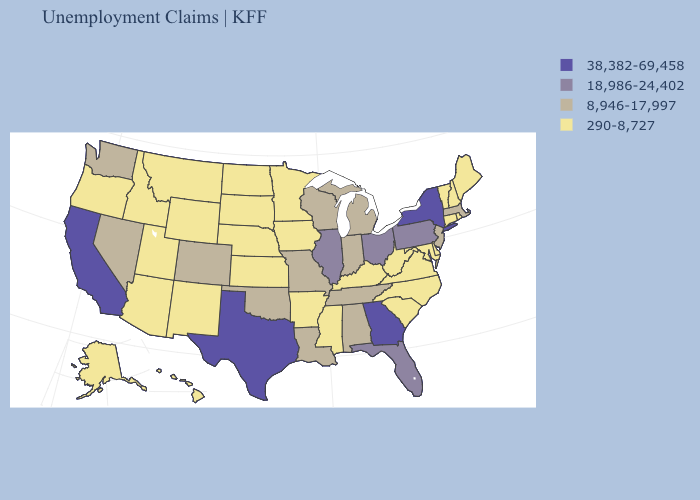Name the states that have a value in the range 290-8,727?
Answer briefly. Alaska, Arizona, Arkansas, Connecticut, Delaware, Hawaii, Idaho, Iowa, Kansas, Kentucky, Maine, Maryland, Minnesota, Mississippi, Montana, Nebraska, New Hampshire, New Mexico, North Carolina, North Dakota, Oregon, Rhode Island, South Carolina, South Dakota, Utah, Vermont, Virginia, West Virginia, Wyoming. Does Virginia have the highest value in the USA?
Quick response, please. No. Name the states that have a value in the range 8,946-17,997?
Answer briefly. Alabama, Colorado, Indiana, Louisiana, Massachusetts, Michigan, Missouri, Nevada, New Jersey, Oklahoma, Tennessee, Washington, Wisconsin. What is the value of South Carolina?
Short answer required. 290-8,727. What is the value of Connecticut?
Write a very short answer. 290-8,727. Among the states that border Minnesota , does Wisconsin have the highest value?
Quick response, please. Yes. Which states have the lowest value in the USA?
Concise answer only. Alaska, Arizona, Arkansas, Connecticut, Delaware, Hawaii, Idaho, Iowa, Kansas, Kentucky, Maine, Maryland, Minnesota, Mississippi, Montana, Nebraska, New Hampshire, New Mexico, North Carolina, North Dakota, Oregon, Rhode Island, South Carolina, South Dakota, Utah, Vermont, Virginia, West Virginia, Wyoming. What is the highest value in states that border Delaware?
Answer briefly. 18,986-24,402. Is the legend a continuous bar?
Keep it brief. No. Name the states that have a value in the range 38,382-69,458?
Keep it brief. California, Georgia, New York, Texas. Name the states that have a value in the range 38,382-69,458?
Write a very short answer. California, Georgia, New York, Texas. What is the lowest value in the West?
Keep it brief. 290-8,727. How many symbols are there in the legend?
Quick response, please. 4. Among the states that border Arkansas , which have the lowest value?
Concise answer only. Mississippi. What is the value of North Carolina?
Be succinct. 290-8,727. 